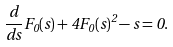<formula> <loc_0><loc_0><loc_500><loc_500>\frac { d } { d s } F _ { 0 } ( s ) + 4 F _ { 0 } ( s ) ^ { 2 } - s = 0 .</formula> 